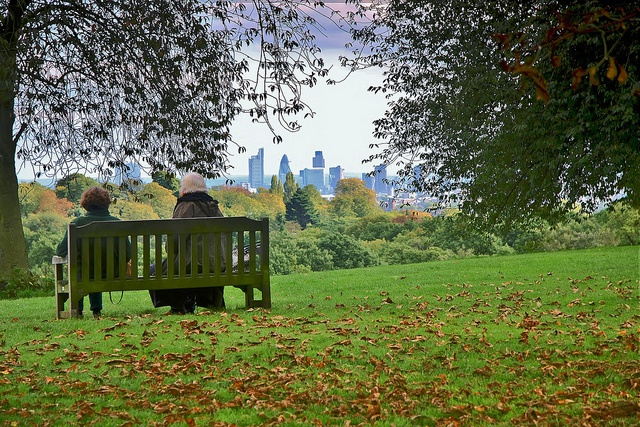Describe the objects in this image and their specific colors. I can see bench in gray, black, and darkgreen tones, people in gray, black, darkgreen, and darkgray tones, people in gray, black, maroon, and darkgreen tones, and handbag in gray, black, and maroon tones in this image. 